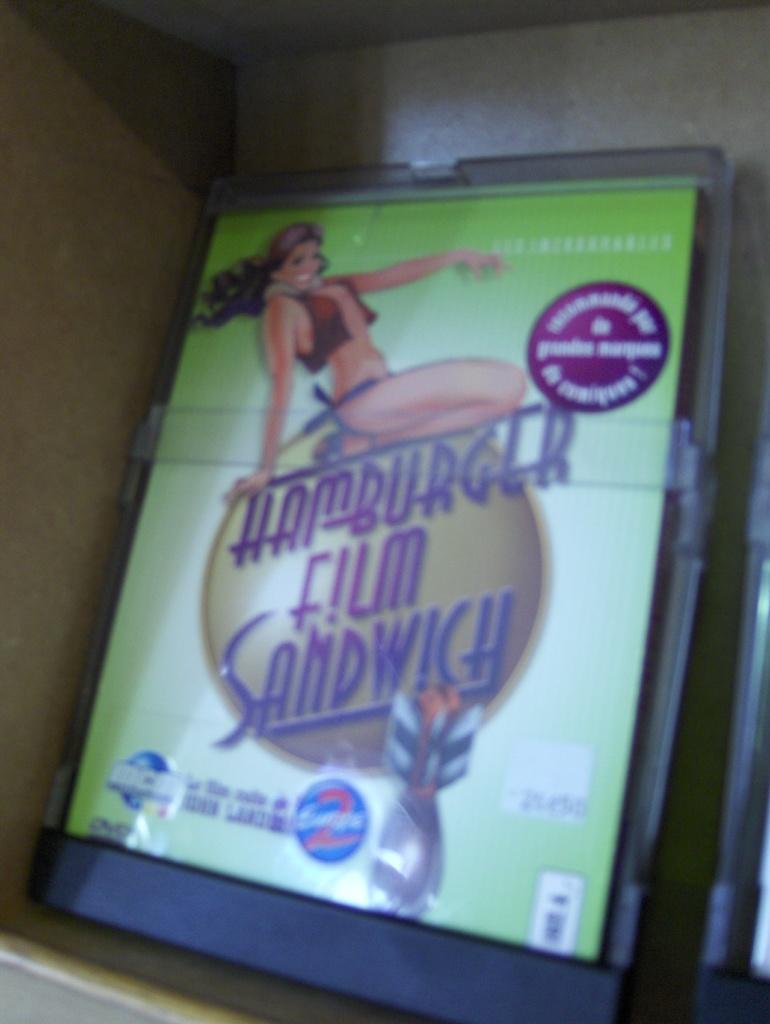How would you summarize this image in a sentence or two? In the given image i can see a advertisement board on which i can see a animated person and some text written on it. 